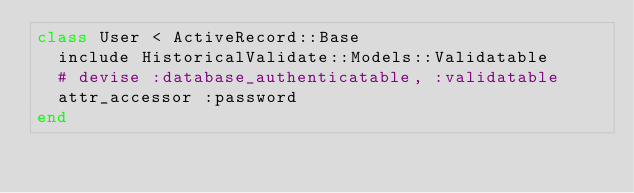Convert code to text. <code><loc_0><loc_0><loc_500><loc_500><_Ruby_>class User < ActiveRecord::Base
  include HistoricalValidate::Models::Validatable
  # devise :database_authenticatable, :validatable
  attr_accessor :password
end
</code> 